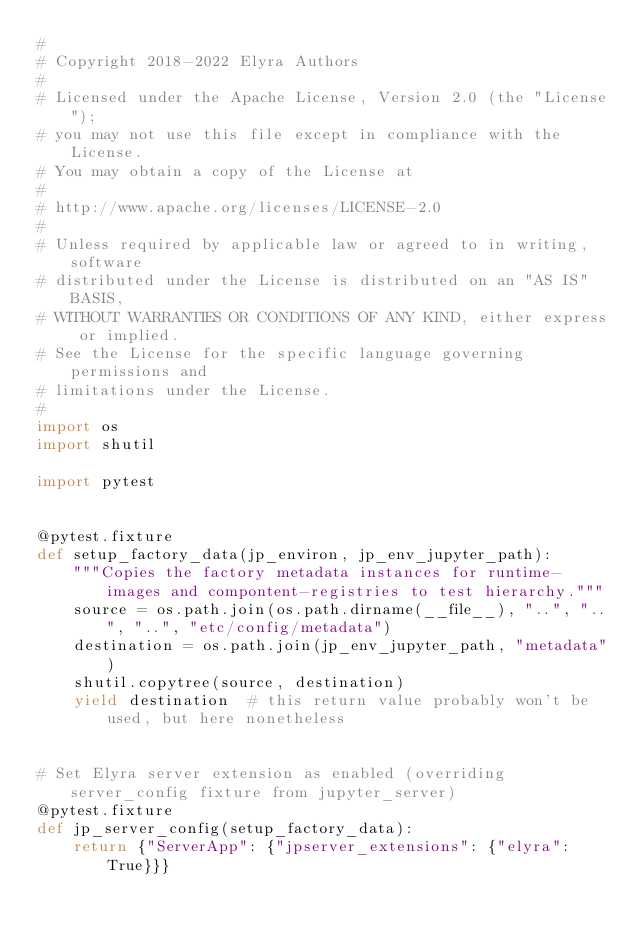Convert code to text. <code><loc_0><loc_0><loc_500><loc_500><_Python_>#
# Copyright 2018-2022 Elyra Authors
#
# Licensed under the Apache License, Version 2.0 (the "License");
# you may not use this file except in compliance with the License.
# You may obtain a copy of the License at
#
# http://www.apache.org/licenses/LICENSE-2.0
#
# Unless required by applicable law or agreed to in writing, software
# distributed under the License is distributed on an "AS IS" BASIS,
# WITHOUT WARRANTIES OR CONDITIONS OF ANY KIND, either express or implied.
# See the License for the specific language governing permissions and
# limitations under the License.
#
import os
import shutil

import pytest


@pytest.fixture
def setup_factory_data(jp_environ, jp_env_jupyter_path):
    """Copies the factory metadata instances for runtime-images and compontent-registries to test hierarchy."""
    source = os.path.join(os.path.dirname(__file__), "..", "..", "..", "etc/config/metadata")
    destination = os.path.join(jp_env_jupyter_path, "metadata")
    shutil.copytree(source, destination)
    yield destination  # this return value probably won't be used, but here nonetheless


# Set Elyra server extension as enabled (overriding server_config fixture from jupyter_server)
@pytest.fixture
def jp_server_config(setup_factory_data):
    return {"ServerApp": {"jpserver_extensions": {"elyra": True}}}
</code> 